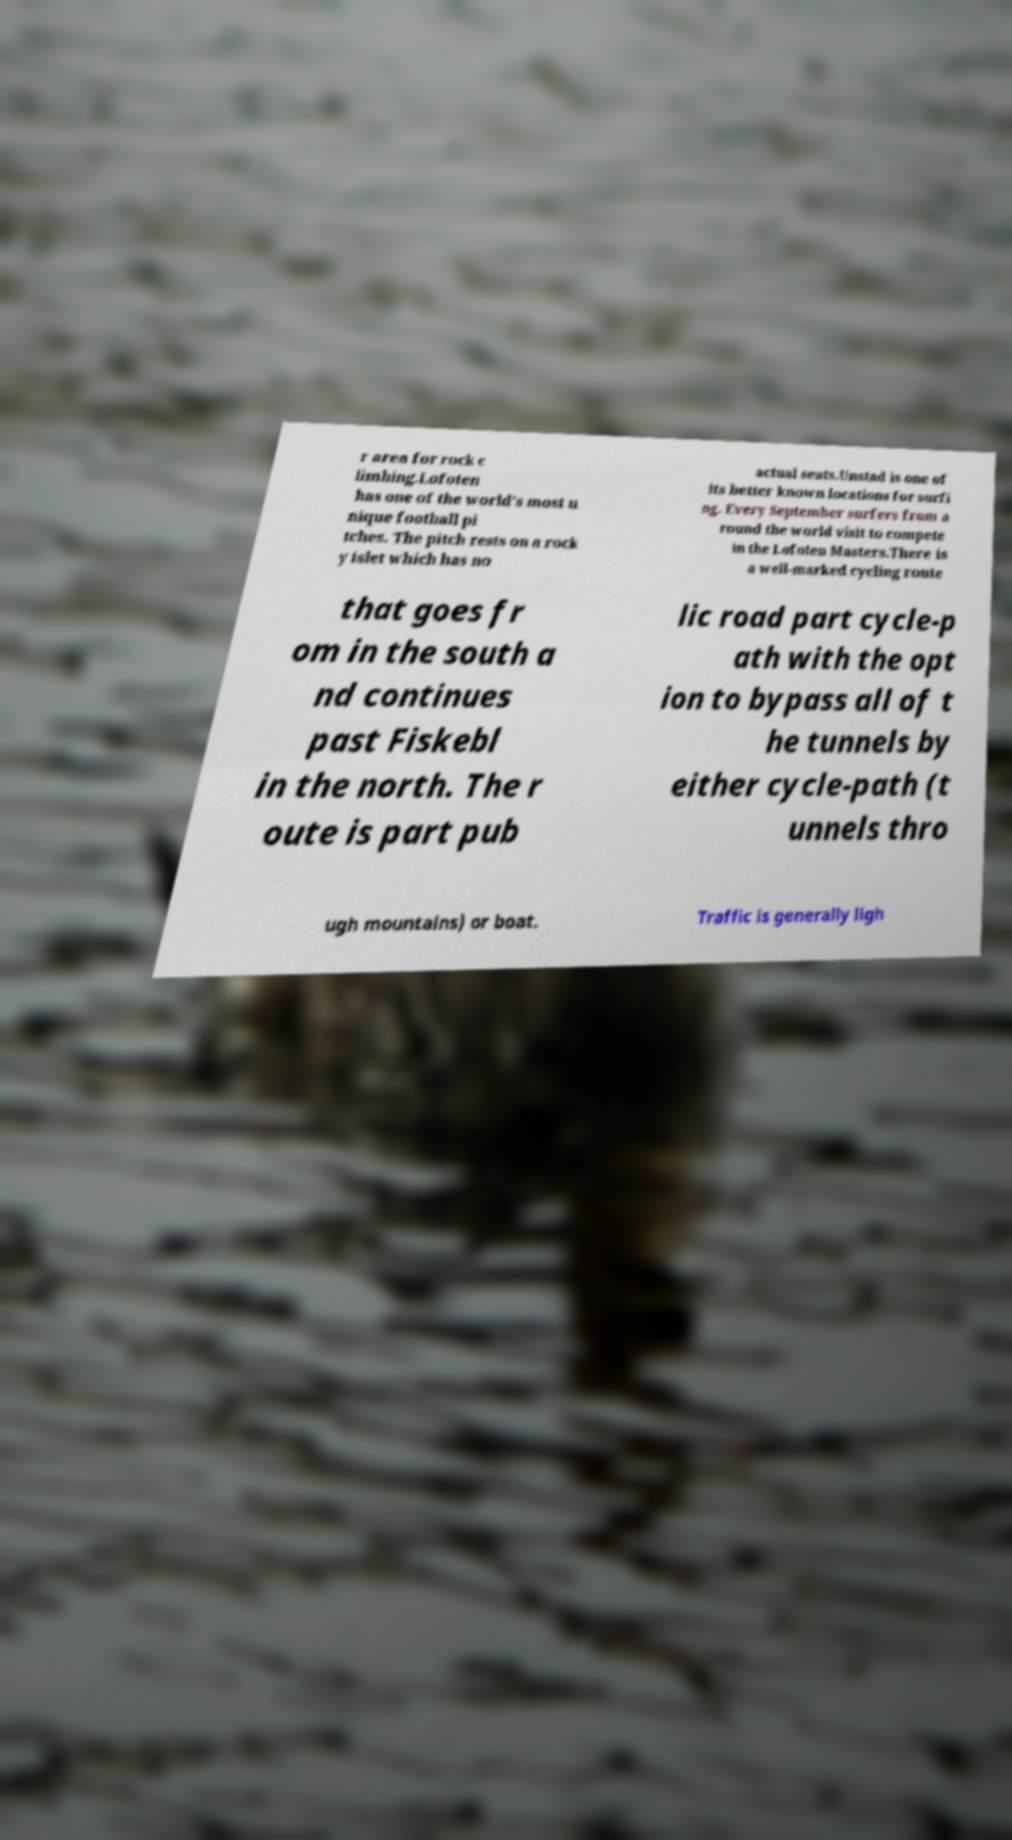Could you extract and type out the text from this image? r area for rock c limbing.Lofoten has one of the world's most u nique football pi tches. The pitch rests on a rock y islet which has no actual seats.Unstad is one of its better known locations for surfi ng. Every September surfers from a round the world visit to compete in the Lofoten Masters.There is a well-marked cycling route that goes fr om in the south a nd continues past Fiskebl in the north. The r oute is part pub lic road part cycle-p ath with the opt ion to bypass all of t he tunnels by either cycle-path (t unnels thro ugh mountains) or boat. Traffic is generally ligh 